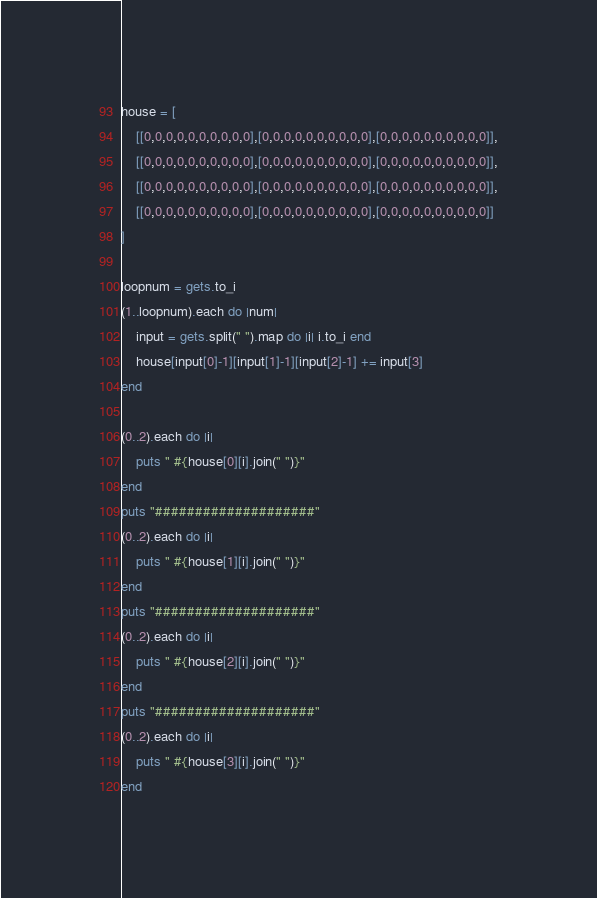Convert code to text. <code><loc_0><loc_0><loc_500><loc_500><_Ruby_>house = [
    [[0,0,0,0,0,0,0,0,0,0],[0,0,0,0,0,0,0,0,0,0],[0,0,0,0,0,0,0,0,0,0]],
    [[0,0,0,0,0,0,0,0,0,0],[0,0,0,0,0,0,0,0,0,0],[0,0,0,0,0,0,0,0,0,0]],
    [[0,0,0,0,0,0,0,0,0,0],[0,0,0,0,0,0,0,0,0,0],[0,0,0,0,0,0,0,0,0,0]],
    [[0,0,0,0,0,0,0,0,0,0],[0,0,0,0,0,0,0,0,0,0],[0,0,0,0,0,0,0,0,0,0]]
]

loopnum = gets.to_i
(1..loopnum).each do |num|
    input = gets.split(" ").map do |i| i.to_i end
    house[input[0]-1][input[1]-1][input[2]-1] += input[3]
end

(0..2).each do |i|
    puts " #{house[0][i].join(" ")}"
end
puts "####################"
(0..2).each do |i|
    puts " #{house[1][i].join(" ")}"
end
puts "####################"
(0..2).each do |i|
    puts " #{house[2][i].join(" ")}"
end
puts "####################"
(0..2).each do |i|
    puts " #{house[3][i].join(" ")}"
end</code> 